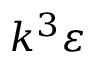<formula> <loc_0><loc_0><loc_500><loc_500>k ^ { 3 } \varepsilon</formula> 